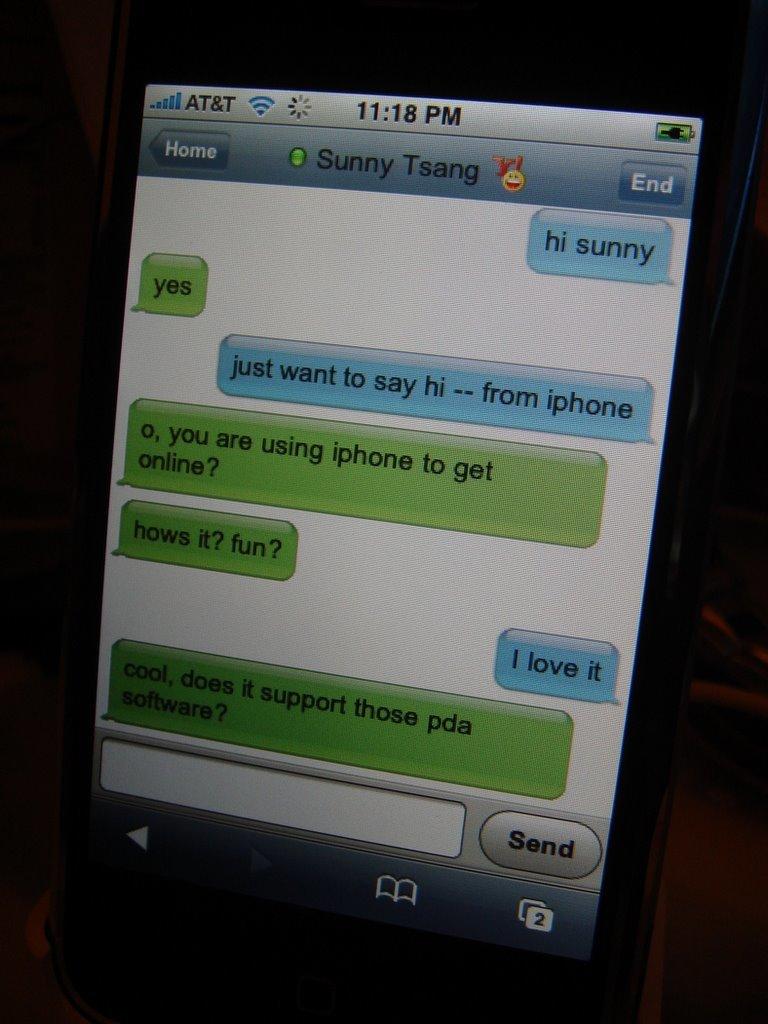Who is this person messaging?
Offer a terse response. Sunny tsang. 